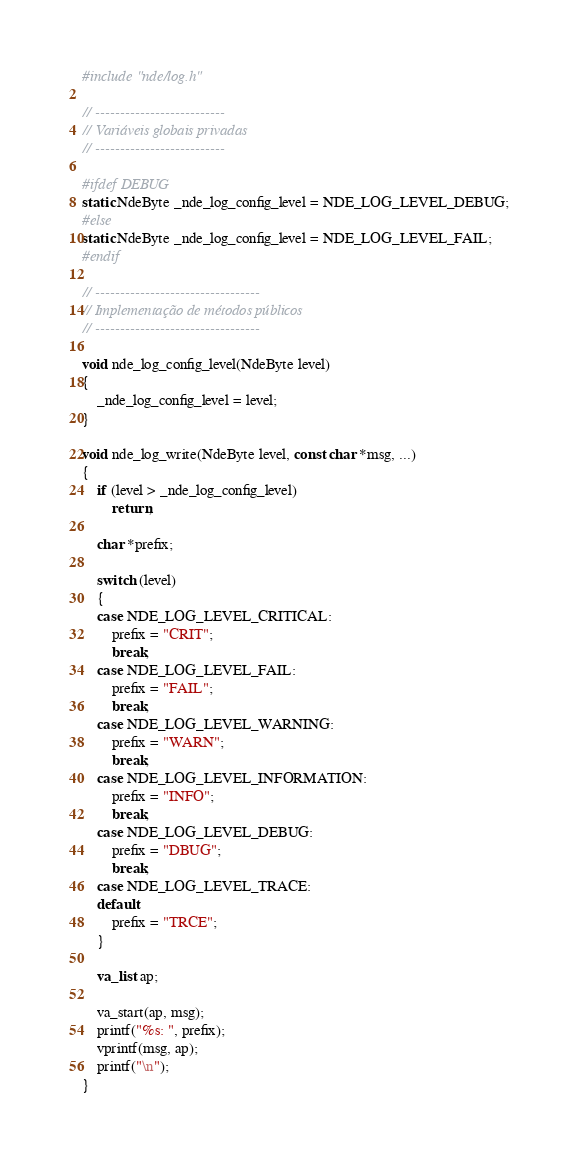<code> <loc_0><loc_0><loc_500><loc_500><_C_>#include "nde/log.h"

// --------------------------
// Variáveis globais privadas
// --------------------------

#ifdef DEBUG
static NdeByte _nde_log_config_level = NDE_LOG_LEVEL_DEBUG;
#else
static NdeByte _nde_log_config_level = NDE_LOG_LEVEL_FAIL;
#endif

// ---------------------------------
// Implementação de métodos públicos
// ---------------------------------

void nde_log_config_level(NdeByte level)
{
    _nde_log_config_level = level;
}

void nde_log_write(NdeByte level, const char *msg, ...)
{
    if (level > _nde_log_config_level)
        return;

    char *prefix;

    switch (level)
    {
    case NDE_LOG_LEVEL_CRITICAL:
        prefix = "CRIT";
        break;
    case NDE_LOG_LEVEL_FAIL:
        prefix = "FAIL";
        break;
    case NDE_LOG_LEVEL_WARNING:
        prefix = "WARN";
        break;
    case NDE_LOG_LEVEL_INFORMATION:
        prefix = "INFO";
        break;
    case NDE_LOG_LEVEL_DEBUG:
        prefix = "DBUG";
        break;
    case NDE_LOG_LEVEL_TRACE:
    default:
        prefix = "TRCE";
    }

    va_list ap;

    va_start(ap, msg);
    printf("%s: ", prefix);
    vprintf(msg, ap);
    printf("\n");
}
</code> 